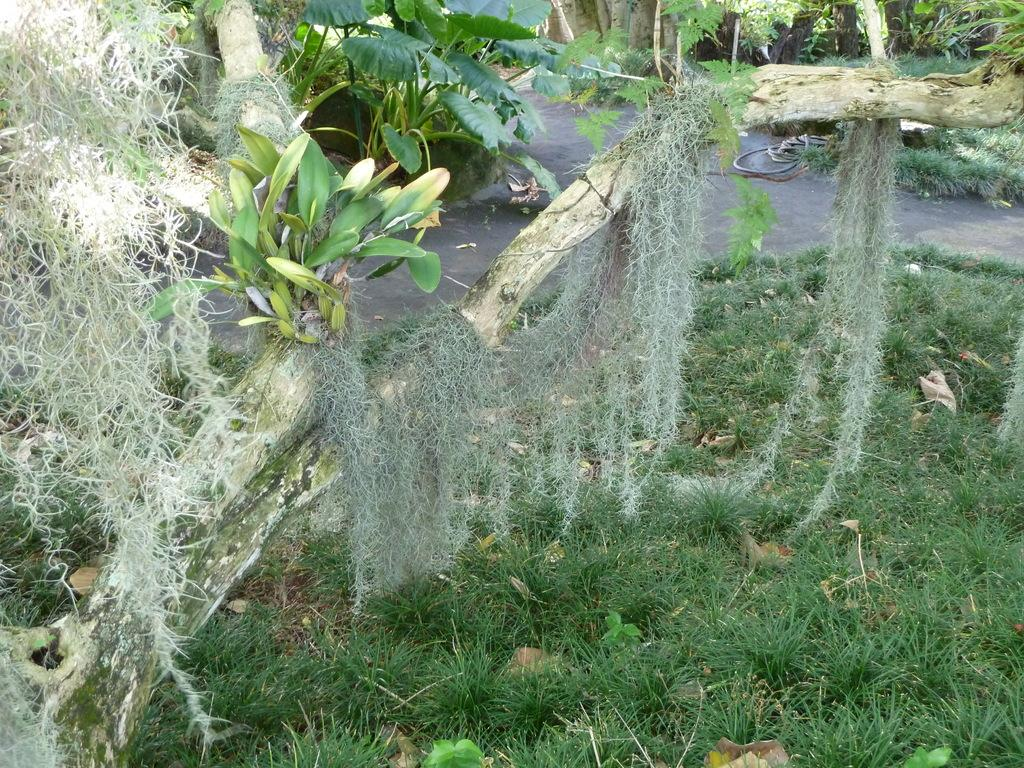What type of vegetation can be seen in the image? There are trees in the image. Where are the trees located? The trees are on a grassland. What else can be seen in the image besides the trees? There is a road in the image. How is the road positioned in relation to the grassland? The road is in the middle of the grassland. How many oranges are hanging from the trees in the image? There are no oranges present in the image; the trees are not fruit-bearing trees. 